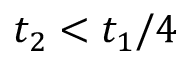<formula> <loc_0><loc_0><loc_500><loc_500>t _ { 2 } < t _ { 1 } / 4</formula> 